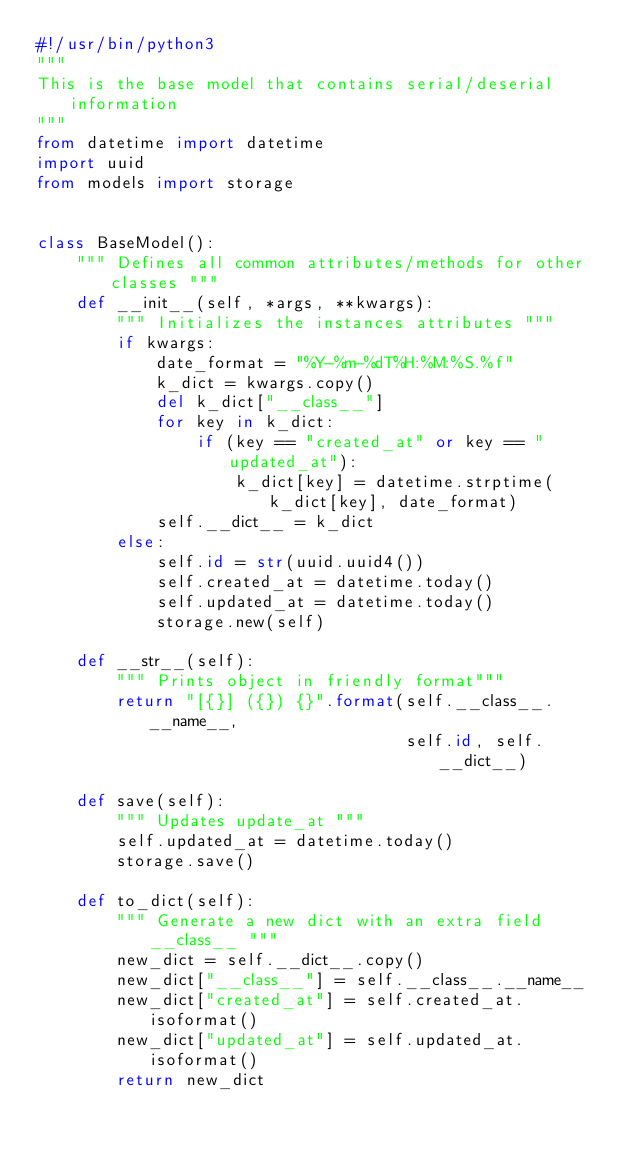Convert code to text. <code><loc_0><loc_0><loc_500><loc_500><_Python_>#!/usr/bin/python3
"""
This is the base model that contains serial/deserial information
"""
from datetime import datetime
import uuid
from models import storage


class BaseModel():
    """ Defines all common attributes/methods for other classes """
    def __init__(self, *args, **kwargs):
        """ Initializes the instances attributes """
        if kwargs:
            date_format = "%Y-%m-%dT%H:%M:%S.%f"
            k_dict = kwargs.copy()
            del k_dict["__class__"]
            for key in k_dict:
                if (key == "created_at" or key == "updated_at"):
                    k_dict[key] = datetime.strptime(k_dict[key], date_format)
            self.__dict__ = k_dict
        else:
            self.id = str(uuid.uuid4())
            self.created_at = datetime.today()
            self.updated_at = datetime.today()
            storage.new(self)

    def __str__(self):
        """ Prints object in friendly format"""
        return "[{}] ({}) {}".format(self.__class__.__name__,
                                     self.id, self.__dict__)

    def save(self):
        """ Updates update_at """
        self.updated_at = datetime.today()
        storage.save()

    def to_dict(self):
        """ Generate a new dict with an extra field __class__ """
        new_dict = self.__dict__.copy()
        new_dict["__class__"] = self.__class__.__name__
        new_dict["created_at"] = self.created_at.isoformat()
        new_dict["updated_at"] = self.updated_at.isoformat()
        return new_dict
</code> 